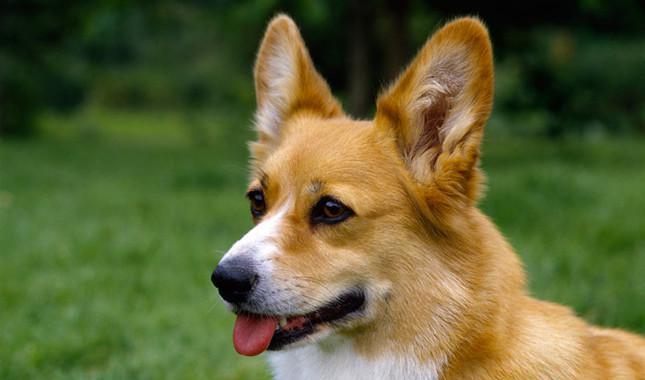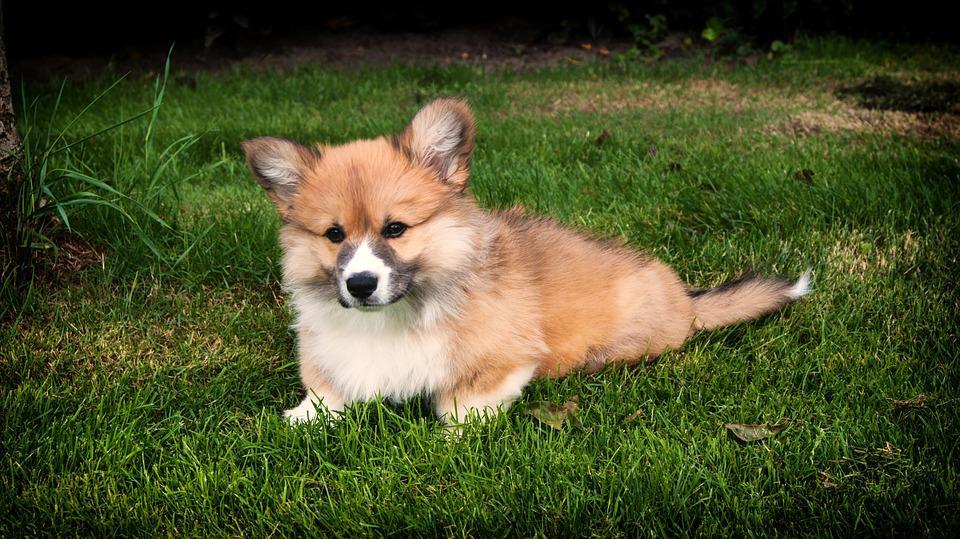The first image is the image on the left, the second image is the image on the right. Assess this claim about the two images: "One dog is standing on the grass.". Correct or not? Answer yes or no. No. 